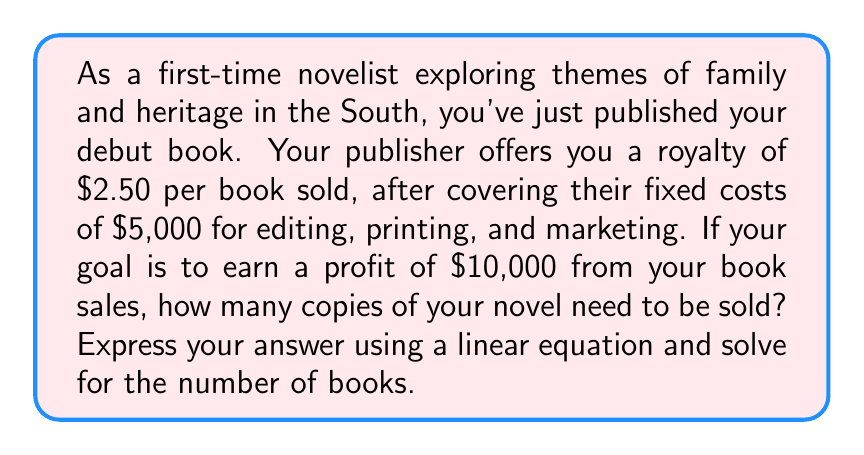Can you solve this math problem? Let's approach this step-by-step using a linear equation:

1) Let $x$ be the number of books sold.

2) Your profit can be expressed as:
   Profit = Revenue - Costs

3) Revenue is the royalty per book multiplied by the number of books sold:
   Revenue = $2.50x$

4) Costs are the fixed costs plus the variable costs (which are already accounted for in the royalty):
   Costs = $5,000

5) Therefore, the profit equation is:
   Profit = $2.50x - 5,000$

6) We want the profit to be $10,000, so we can set up the equation:
   $10,000 = 2.50x - 5,000$

7) Solve for $x$:
   $10,000 + 5,000 = 2.50x$
   $15,000 = 2.50x$

8) Divide both sides by 2.50:
   $\frac{15,000}{2.50} = x$
   $6,000 = x$

Therefore, you need to sell 6,000 copies of your novel to make a profit of $10,000.

To verify:
Profit = $2.50(6,000) - 5,000 = 15,000 - 5,000 = 10,000$
Answer: You need to sell 6,000 copies of your novel to make a profit of $10,000. The linear equation representing this scenario is:

$$10,000 = 2.50x - 5,000$$

where $x$ is the number of books sold. 